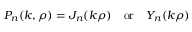Convert formula to latex. <formula><loc_0><loc_0><loc_500><loc_500>P _ { n } ( k , \rho ) = J _ { n } ( k \rho ) \, o r \, Y _ { n } ( k \rho )</formula> 